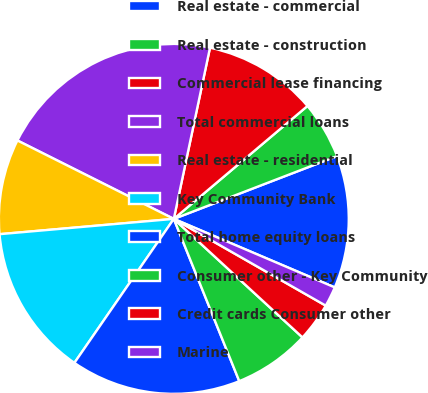Convert chart to OTSL. <chart><loc_0><loc_0><loc_500><loc_500><pie_chart><fcel>Real estate - commercial<fcel>Real estate - construction<fcel>Commercial lease financing<fcel>Total commercial loans<fcel>Real estate - residential<fcel>Key Community Bank<fcel>Total home equity loans<fcel>Consumer other - Key Community<fcel>Credit cards Consumer other<fcel>Marine<nl><fcel>12.25%<fcel>5.32%<fcel>10.52%<fcel>20.92%<fcel>8.79%<fcel>13.99%<fcel>15.72%<fcel>7.05%<fcel>3.59%<fcel>1.85%<nl></chart> 